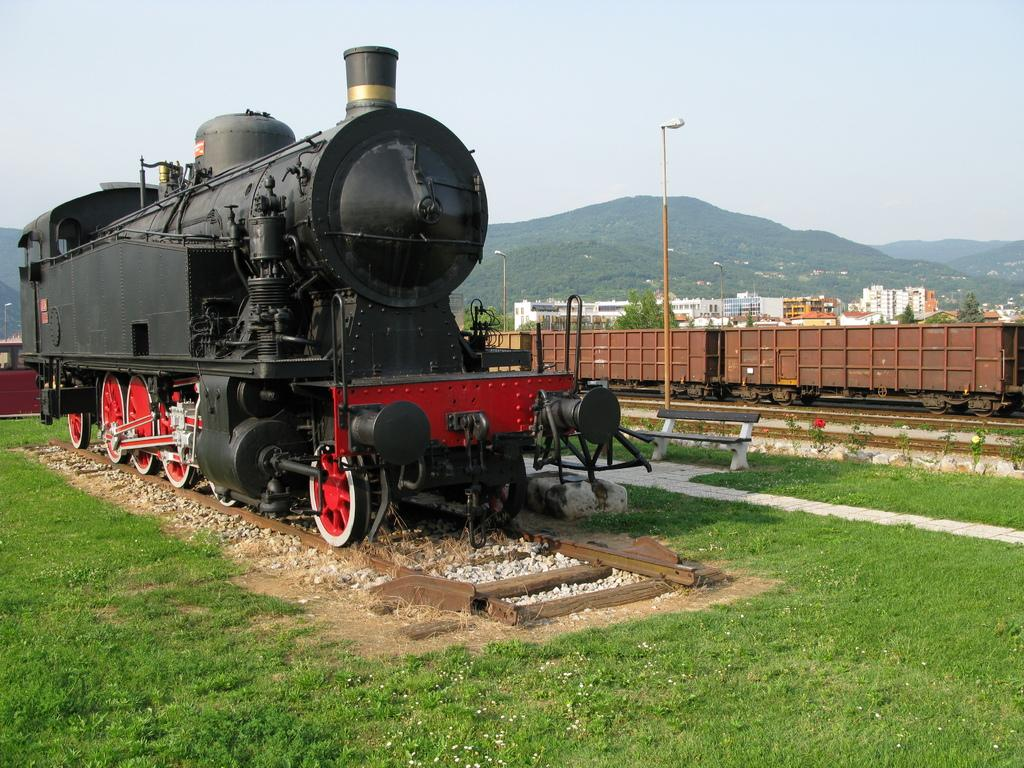How many trains are on the railway track in the image? There are two trains on the railway track in the image. What type of seating is available in the image? There is a bench in the image. What type of lighting is present in the image? There is a street light in the image. What type of vegetation is present on the ground? Grass is present on the ground. What type of structures are visible in the background? There are buildings in the background. What type of natural features are visible in the background? Trees and mountains are visible in the background. What part of the natural environment is visible in the background? The sky is visible in the background. How many pets are visible in the image? There are no pets visible in the image. What type of field is present in the image? There is no field present in the image. 